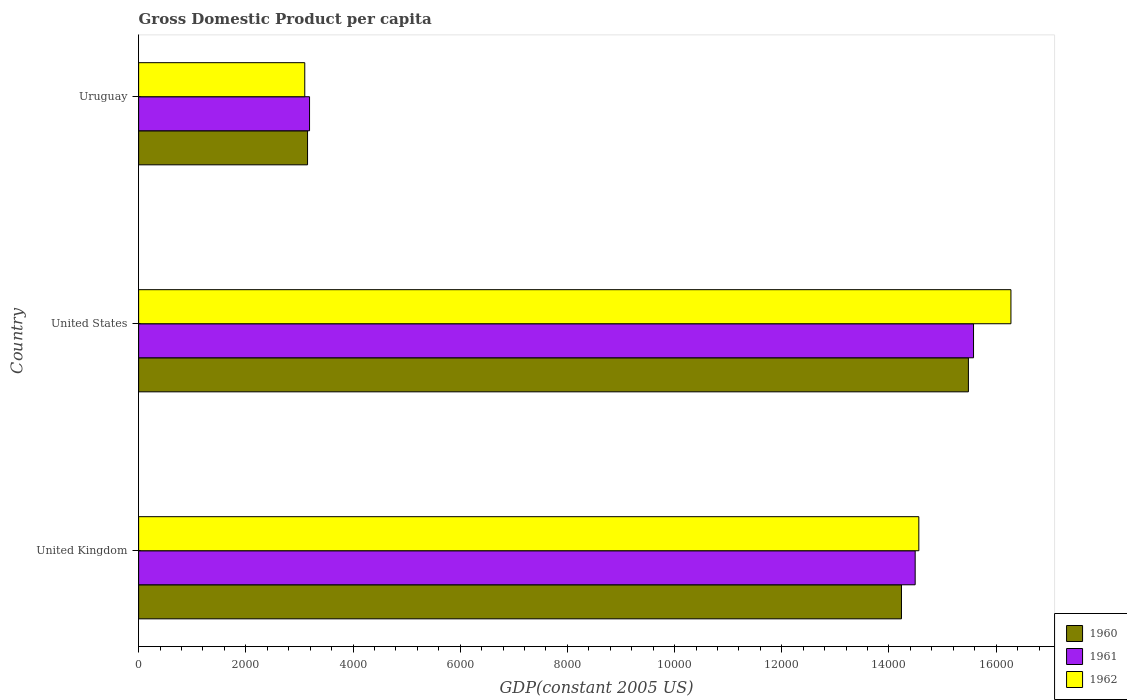How many groups of bars are there?
Provide a succinct answer. 3. Are the number of bars per tick equal to the number of legend labels?
Your answer should be very brief. Yes. How many bars are there on the 3rd tick from the top?
Provide a short and direct response. 3. How many bars are there on the 1st tick from the bottom?
Ensure brevity in your answer.  3. What is the GDP per capita in 1962 in Uruguay?
Your answer should be compact. 3100.01. Across all countries, what is the maximum GDP per capita in 1960?
Provide a short and direct response. 1.55e+04. Across all countries, what is the minimum GDP per capita in 1962?
Offer a terse response. 3100.01. In which country was the GDP per capita in 1962 maximum?
Give a very brief answer. United States. In which country was the GDP per capita in 1961 minimum?
Offer a very short reply. Uruguay. What is the total GDP per capita in 1962 in the graph?
Offer a very short reply. 3.39e+04. What is the difference between the GDP per capita in 1962 in United Kingdom and that in Uruguay?
Provide a succinct answer. 1.15e+04. What is the difference between the GDP per capita in 1960 in United Kingdom and the GDP per capita in 1962 in United States?
Keep it short and to the point. -2042.71. What is the average GDP per capita in 1961 per country?
Provide a short and direct response. 1.11e+04. What is the difference between the GDP per capita in 1961 and GDP per capita in 1962 in United States?
Give a very brief answer. -698.02. In how many countries, is the GDP per capita in 1961 greater than 16000 US$?
Provide a succinct answer. 0. What is the ratio of the GDP per capita in 1960 in United Kingdom to that in Uruguay?
Your answer should be compact. 4.52. Is the difference between the GDP per capita in 1961 in United Kingdom and Uruguay greater than the difference between the GDP per capita in 1962 in United Kingdom and Uruguay?
Provide a succinct answer. No. What is the difference between the highest and the second highest GDP per capita in 1962?
Give a very brief answer. 1718.65. What is the difference between the highest and the lowest GDP per capita in 1960?
Offer a very short reply. 1.23e+04. In how many countries, is the GDP per capita in 1961 greater than the average GDP per capita in 1961 taken over all countries?
Provide a succinct answer. 2. Is the sum of the GDP per capita in 1960 in United States and Uruguay greater than the maximum GDP per capita in 1962 across all countries?
Provide a short and direct response. Yes. What does the 3rd bar from the top in United States represents?
Make the answer very short. 1960. Is it the case that in every country, the sum of the GDP per capita in 1961 and GDP per capita in 1960 is greater than the GDP per capita in 1962?
Make the answer very short. Yes. How many bars are there?
Offer a terse response. 9. Are all the bars in the graph horizontal?
Ensure brevity in your answer.  Yes. How many countries are there in the graph?
Ensure brevity in your answer.  3. What is the difference between two consecutive major ticks on the X-axis?
Provide a succinct answer. 2000. How many legend labels are there?
Your answer should be compact. 3. What is the title of the graph?
Provide a short and direct response. Gross Domestic Product per capita. Does "2008" appear as one of the legend labels in the graph?
Your answer should be compact. No. What is the label or title of the X-axis?
Ensure brevity in your answer.  GDP(constant 2005 US). What is the GDP(constant 2005 US) of 1960 in United Kingdom?
Provide a short and direct response. 1.42e+04. What is the GDP(constant 2005 US) in 1961 in United Kingdom?
Offer a very short reply. 1.45e+04. What is the GDP(constant 2005 US) in 1962 in United Kingdom?
Provide a succinct answer. 1.46e+04. What is the GDP(constant 2005 US) in 1960 in United States?
Offer a terse response. 1.55e+04. What is the GDP(constant 2005 US) in 1961 in United States?
Ensure brevity in your answer.  1.56e+04. What is the GDP(constant 2005 US) of 1962 in United States?
Keep it short and to the point. 1.63e+04. What is the GDP(constant 2005 US) in 1960 in Uruguay?
Offer a terse response. 3151.96. What is the GDP(constant 2005 US) in 1961 in Uruguay?
Provide a short and direct response. 3189.04. What is the GDP(constant 2005 US) in 1962 in Uruguay?
Give a very brief answer. 3100.01. Across all countries, what is the maximum GDP(constant 2005 US) of 1960?
Ensure brevity in your answer.  1.55e+04. Across all countries, what is the maximum GDP(constant 2005 US) of 1961?
Provide a short and direct response. 1.56e+04. Across all countries, what is the maximum GDP(constant 2005 US) in 1962?
Your answer should be compact. 1.63e+04. Across all countries, what is the minimum GDP(constant 2005 US) of 1960?
Keep it short and to the point. 3151.96. Across all countries, what is the minimum GDP(constant 2005 US) of 1961?
Provide a succinct answer. 3189.04. Across all countries, what is the minimum GDP(constant 2005 US) in 1962?
Your answer should be very brief. 3100.01. What is the total GDP(constant 2005 US) in 1960 in the graph?
Ensure brevity in your answer.  3.29e+04. What is the total GDP(constant 2005 US) of 1961 in the graph?
Make the answer very short. 3.33e+04. What is the total GDP(constant 2005 US) in 1962 in the graph?
Your response must be concise. 3.39e+04. What is the difference between the GDP(constant 2005 US) of 1960 in United Kingdom and that in United States?
Your response must be concise. -1248.99. What is the difference between the GDP(constant 2005 US) in 1961 in United Kingdom and that in United States?
Your response must be concise. -1088.98. What is the difference between the GDP(constant 2005 US) of 1962 in United Kingdom and that in United States?
Provide a short and direct response. -1718.65. What is the difference between the GDP(constant 2005 US) of 1960 in United Kingdom and that in Uruguay?
Provide a short and direct response. 1.11e+04. What is the difference between the GDP(constant 2005 US) of 1961 in United Kingdom and that in Uruguay?
Provide a short and direct response. 1.13e+04. What is the difference between the GDP(constant 2005 US) in 1962 in United Kingdom and that in Uruguay?
Your answer should be very brief. 1.15e+04. What is the difference between the GDP(constant 2005 US) of 1960 in United States and that in Uruguay?
Provide a short and direct response. 1.23e+04. What is the difference between the GDP(constant 2005 US) of 1961 in United States and that in Uruguay?
Offer a terse response. 1.24e+04. What is the difference between the GDP(constant 2005 US) of 1962 in United States and that in Uruguay?
Keep it short and to the point. 1.32e+04. What is the difference between the GDP(constant 2005 US) of 1960 in United Kingdom and the GDP(constant 2005 US) of 1961 in United States?
Keep it short and to the point. -1344.69. What is the difference between the GDP(constant 2005 US) of 1960 in United Kingdom and the GDP(constant 2005 US) of 1962 in United States?
Ensure brevity in your answer.  -2042.71. What is the difference between the GDP(constant 2005 US) in 1961 in United Kingdom and the GDP(constant 2005 US) in 1962 in United States?
Ensure brevity in your answer.  -1787. What is the difference between the GDP(constant 2005 US) in 1960 in United Kingdom and the GDP(constant 2005 US) in 1961 in Uruguay?
Provide a succinct answer. 1.10e+04. What is the difference between the GDP(constant 2005 US) in 1960 in United Kingdom and the GDP(constant 2005 US) in 1962 in Uruguay?
Ensure brevity in your answer.  1.11e+04. What is the difference between the GDP(constant 2005 US) in 1961 in United Kingdom and the GDP(constant 2005 US) in 1962 in Uruguay?
Your answer should be compact. 1.14e+04. What is the difference between the GDP(constant 2005 US) in 1960 in United States and the GDP(constant 2005 US) in 1961 in Uruguay?
Your response must be concise. 1.23e+04. What is the difference between the GDP(constant 2005 US) in 1960 in United States and the GDP(constant 2005 US) in 1962 in Uruguay?
Provide a short and direct response. 1.24e+04. What is the difference between the GDP(constant 2005 US) of 1961 in United States and the GDP(constant 2005 US) of 1962 in Uruguay?
Your response must be concise. 1.25e+04. What is the average GDP(constant 2005 US) in 1960 per country?
Make the answer very short. 1.10e+04. What is the average GDP(constant 2005 US) of 1961 per country?
Ensure brevity in your answer.  1.11e+04. What is the average GDP(constant 2005 US) of 1962 per country?
Provide a short and direct response. 1.13e+04. What is the difference between the GDP(constant 2005 US) of 1960 and GDP(constant 2005 US) of 1961 in United Kingdom?
Provide a succinct answer. -255.71. What is the difference between the GDP(constant 2005 US) of 1960 and GDP(constant 2005 US) of 1962 in United Kingdom?
Offer a very short reply. -324.06. What is the difference between the GDP(constant 2005 US) in 1961 and GDP(constant 2005 US) in 1962 in United Kingdom?
Your answer should be very brief. -68.35. What is the difference between the GDP(constant 2005 US) in 1960 and GDP(constant 2005 US) in 1961 in United States?
Provide a short and direct response. -95.7. What is the difference between the GDP(constant 2005 US) of 1960 and GDP(constant 2005 US) of 1962 in United States?
Your answer should be compact. -793.72. What is the difference between the GDP(constant 2005 US) in 1961 and GDP(constant 2005 US) in 1962 in United States?
Provide a short and direct response. -698.02. What is the difference between the GDP(constant 2005 US) in 1960 and GDP(constant 2005 US) in 1961 in Uruguay?
Offer a very short reply. -37.08. What is the difference between the GDP(constant 2005 US) in 1960 and GDP(constant 2005 US) in 1962 in Uruguay?
Offer a very short reply. 51.95. What is the difference between the GDP(constant 2005 US) in 1961 and GDP(constant 2005 US) in 1962 in Uruguay?
Offer a terse response. 89.02. What is the ratio of the GDP(constant 2005 US) of 1960 in United Kingdom to that in United States?
Your answer should be very brief. 0.92. What is the ratio of the GDP(constant 2005 US) in 1961 in United Kingdom to that in United States?
Offer a terse response. 0.93. What is the ratio of the GDP(constant 2005 US) of 1962 in United Kingdom to that in United States?
Keep it short and to the point. 0.89. What is the ratio of the GDP(constant 2005 US) of 1960 in United Kingdom to that in Uruguay?
Offer a terse response. 4.52. What is the ratio of the GDP(constant 2005 US) in 1961 in United Kingdom to that in Uruguay?
Your answer should be very brief. 4.54. What is the ratio of the GDP(constant 2005 US) in 1962 in United Kingdom to that in Uruguay?
Give a very brief answer. 4.7. What is the ratio of the GDP(constant 2005 US) of 1960 in United States to that in Uruguay?
Provide a succinct answer. 4.91. What is the ratio of the GDP(constant 2005 US) in 1961 in United States to that in Uruguay?
Make the answer very short. 4.88. What is the ratio of the GDP(constant 2005 US) of 1962 in United States to that in Uruguay?
Your answer should be compact. 5.25. What is the difference between the highest and the second highest GDP(constant 2005 US) of 1960?
Provide a succinct answer. 1248.99. What is the difference between the highest and the second highest GDP(constant 2005 US) of 1961?
Ensure brevity in your answer.  1088.98. What is the difference between the highest and the second highest GDP(constant 2005 US) of 1962?
Make the answer very short. 1718.65. What is the difference between the highest and the lowest GDP(constant 2005 US) in 1960?
Provide a succinct answer. 1.23e+04. What is the difference between the highest and the lowest GDP(constant 2005 US) of 1961?
Offer a very short reply. 1.24e+04. What is the difference between the highest and the lowest GDP(constant 2005 US) of 1962?
Make the answer very short. 1.32e+04. 